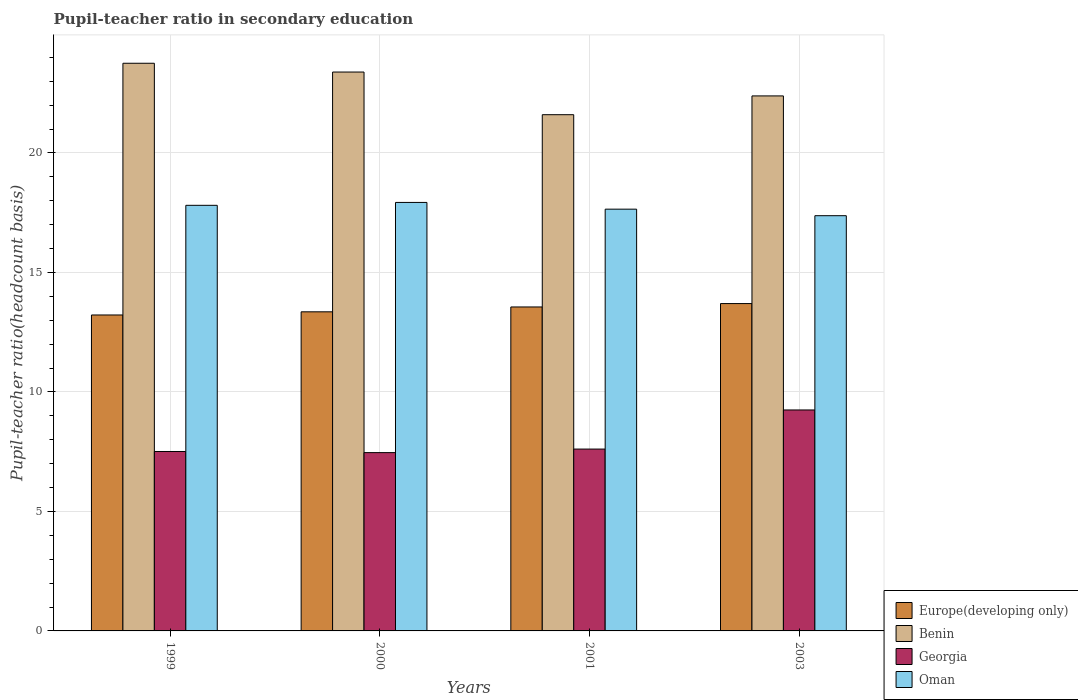How many different coloured bars are there?
Your answer should be very brief. 4. How many groups of bars are there?
Offer a terse response. 4. What is the pupil-teacher ratio in secondary education in Georgia in 1999?
Give a very brief answer. 7.51. Across all years, what is the maximum pupil-teacher ratio in secondary education in Georgia?
Keep it short and to the point. 9.25. Across all years, what is the minimum pupil-teacher ratio in secondary education in Oman?
Your answer should be very brief. 17.37. In which year was the pupil-teacher ratio in secondary education in Benin minimum?
Offer a very short reply. 2001. What is the total pupil-teacher ratio in secondary education in Benin in the graph?
Your answer should be compact. 91.12. What is the difference between the pupil-teacher ratio in secondary education in Oman in 2001 and that in 2003?
Give a very brief answer. 0.27. What is the difference between the pupil-teacher ratio in secondary education in Europe(developing only) in 2001 and the pupil-teacher ratio in secondary education in Georgia in 1999?
Give a very brief answer. 6.05. What is the average pupil-teacher ratio in secondary education in Europe(developing only) per year?
Keep it short and to the point. 13.46. In the year 2003, what is the difference between the pupil-teacher ratio in secondary education in Georgia and pupil-teacher ratio in secondary education in Europe(developing only)?
Give a very brief answer. -4.45. What is the ratio of the pupil-teacher ratio in secondary education in Benin in 2000 to that in 2001?
Offer a terse response. 1.08. Is the difference between the pupil-teacher ratio in secondary education in Georgia in 1999 and 2003 greater than the difference between the pupil-teacher ratio in secondary education in Europe(developing only) in 1999 and 2003?
Make the answer very short. No. What is the difference between the highest and the second highest pupil-teacher ratio in secondary education in Europe(developing only)?
Ensure brevity in your answer.  0.14. What is the difference between the highest and the lowest pupil-teacher ratio in secondary education in Europe(developing only)?
Your response must be concise. 0.48. Is the sum of the pupil-teacher ratio in secondary education in Oman in 2001 and 2003 greater than the maximum pupil-teacher ratio in secondary education in Benin across all years?
Provide a succinct answer. Yes. What does the 4th bar from the left in 1999 represents?
Keep it short and to the point. Oman. What does the 3rd bar from the right in 2000 represents?
Give a very brief answer. Benin. Is it the case that in every year, the sum of the pupil-teacher ratio in secondary education in Oman and pupil-teacher ratio in secondary education in Benin is greater than the pupil-teacher ratio in secondary education in Georgia?
Your answer should be very brief. Yes. What is the difference between two consecutive major ticks on the Y-axis?
Offer a terse response. 5. Are the values on the major ticks of Y-axis written in scientific E-notation?
Offer a very short reply. No. Does the graph contain any zero values?
Ensure brevity in your answer.  No. Where does the legend appear in the graph?
Your answer should be compact. Bottom right. How many legend labels are there?
Provide a short and direct response. 4. How are the legend labels stacked?
Your answer should be compact. Vertical. What is the title of the graph?
Your answer should be compact. Pupil-teacher ratio in secondary education. What is the label or title of the Y-axis?
Ensure brevity in your answer.  Pupil-teacher ratio(headcount basis). What is the Pupil-teacher ratio(headcount basis) in Europe(developing only) in 1999?
Provide a succinct answer. 13.22. What is the Pupil-teacher ratio(headcount basis) in Benin in 1999?
Ensure brevity in your answer.  23.75. What is the Pupil-teacher ratio(headcount basis) of Georgia in 1999?
Offer a terse response. 7.51. What is the Pupil-teacher ratio(headcount basis) of Oman in 1999?
Provide a succinct answer. 17.81. What is the Pupil-teacher ratio(headcount basis) in Europe(developing only) in 2000?
Your answer should be very brief. 13.35. What is the Pupil-teacher ratio(headcount basis) in Benin in 2000?
Offer a terse response. 23.38. What is the Pupil-teacher ratio(headcount basis) of Georgia in 2000?
Your answer should be very brief. 7.46. What is the Pupil-teacher ratio(headcount basis) in Oman in 2000?
Offer a very short reply. 17.93. What is the Pupil-teacher ratio(headcount basis) in Europe(developing only) in 2001?
Ensure brevity in your answer.  13.55. What is the Pupil-teacher ratio(headcount basis) in Benin in 2001?
Make the answer very short. 21.6. What is the Pupil-teacher ratio(headcount basis) of Georgia in 2001?
Keep it short and to the point. 7.61. What is the Pupil-teacher ratio(headcount basis) in Oman in 2001?
Your answer should be very brief. 17.65. What is the Pupil-teacher ratio(headcount basis) in Europe(developing only) in 2003?
Provide a succinct answer. 13.7. What is the Pupil-teacher ratio(headcount basis) in Benin in 2003?
Provide a short and direct response. 22.38. What is the Pupil-teacher ratio(headcount basis) of Georgia in 2003?
Offer a very short reply. 9.25. What is the Pupil-teacher ratio(headcount basis) of Oman in 2003?
Provide a short and direct response. 17.37. Across all years, what is the maximum Pupil-teacher ratio(headcount basis) in Europe(developing only)?
Offer a terse response. 13.7. Across all years, what is the maximum Pupil-teacher ratio(headcount basis) in Benin?
Ensure brevity in your answer.  23.75. Across all years, what is the maximum Pupil-teacher ratio(headcount basis) in Georgia?
Make the answer very short. 9.25. Across all years, what is the maximum Pupil-teacher ratio(headcount basis) in Oman?
Keep it short and to the point. 17.93. Across all years, what is the minimum Pupil-teacher ratio(headcount basis) of Europe(developing only)?
Ensure brevity in your answer.  13.22. Across all years, what is the minimum Pupil-teacher ratio(headcount basis) of Benin?
Make the answer very short. 21.6. Across all years, what is the minimum Pupil-teacher ratio(headcount basis) in Georgia?
Your response must be concise. 7.46. Across all years, what is the minimum Pupil-teacher ratio(headcount basis) of Oman?
Give a very brief answer. 17.37. What is the total Pupil-teacher ratio(headcount basis) of Europe(developing only) in the graph?
Offer a terse response. 53.82. What is the total Pupil-teacher ratio(headcount basis) in Benin in the graph?
Your answer should be very brief. 91.12. What is the total Pupil-teacher ratio(headcount basis) of Georgia in the graph?
Provide a short and direct response. 31.82. What is the total Pupil-teacher ratio(headcount basis) in Oman in the graph?
Ensure brevity in your answer.  70.75. What is the difference between the Pupil-teacher ratio(headcount basis) in Europe(developing only) in 1999 and that in 2000?
Keep it short and to the point. -0.13. What is the difference between the Pupil-teacher ratio(headcount basis) in Benin in 1999 and that in 2000?
Your answer should be compact. 0.37. What is the difference between the Pupil-teacher ratio(headcount basis) of Georgia in 1999 and that in 2000?
Your answer should be very brief. 0.05. What is the difference between the Pupil-teacher ratio(headcount basis) in Oman in 1999 and that in 2000?
Give a very brief answer. -0.12. What is the difference between the Pupil-teacher ratio(headcount basis) in Europe(developing only) in 1999 and that in 2001?
Provide a short and direct response. -0.34. What is the difference between the Pupil-teacher ratio(headcount basis) of Benin in 1999 and that in 2001?
Your answer should be very brief. 2.15. What is the difference between the Pupil-teacher ratio(headcount basis) in Georgia in 1999 and that in 2001?
Provide a short and direct response. -0.1. What is the difference between the Pupil-teacher ratio(headcount basis) in Oman in 1999 and that in 2001?
Ensure brevity in your answer.  0.16. What is the difference between the Pupil-teacher ratio(headcount basis) of Europe(developing only) in 1999 and that in 2003?
Provide a succinct answer. -0.48. What is the difference between the Pupil-teacher ratio(headcount basis) of Benin in 1999 and that in 2003?
Keep it short and to the point. 1.37. What is the difference between the Pupil-teacher ratio(headcount basis) of Georgia in 1999 and that in 2003?
Offer a terse response. -1.74. What is the difference between the Pupil-teacher ratio(headcount basis) in Oman in 1999 and that in 2003?
Your response must be concise. 0.43. What is the difference between the Pupil-teacher ratio(headcount basis) of Europe(developing only) in 2000 and that in 2001?
Keep it short and to the point. -0.2. What is the difference between the Pupil-teacher ratio(headcount basis) in Benin in 2000 and that in 2001?
Your response must be concise. 1.78. What is the difference between the Pupil-teacher ratio(headcount basis) of Georgia in 2000 and that in 2001?
Offer a very short reply. -0.15. What is the difference between the Pupil-teacher ratio(headcount basis) in Oman in 2000 and that in 2001?
Make the answer very short. 0.28. What is the difference between the Pupil-teacher ratio(headcount basis) in Europe(developing only) in 2000 and that in 2003?
Your answer should be very brief. -0.35. What is the difference between the Pupil-teacher ratio(headcount basis) in Georgia in 2000 and that in 2003?
Your response must be concise. -1.78. What is the difference between the Pupil-teacher ratio(headcount basis) in Oman in 2000 and that in 2003?
Keep it short and to the point. 0.56. What is the difference between the Pupil-teacher ratio(headcount basis) in Europe(developing only) in 2001 and that in 2003?
Offer a terse response. -0.14. What is the difference between the Pupil-teacher ratio(headcount basis) of Benin in 2001 and that in 2003?
Provide a succinct answer. -0.79. What is the difference between the Pupil-teacher ratio(headcount basis) of Georgia in 2001 and that in 2003?
Your answer should be compact. -1.64. What is the difference between the Pupil-teacher ratio(headcount basis) in Oman in 2001 and that in 2003?
Provide a succinct answer. 0.27. What is the difference between the Pupil-teacher ratio(headcount basis) in Europe(developing only) in 1999 and the Pupil-teacher ratio(headcount basis) in Benin in 2000?
Your answer should be compact. -10.16. What is the difference between the Pupil-teacher ratio(headcount basis) of Europe(developing only) in 1999 and the Pupil-teacher ratio(headcount basis) of Georgia in 2000?
Make the answer very short. 5.76. What is the difference between the Pupil-teacher ratio(headcount basis) in Europe(developing only) in 1999 and the Pupil-teacher ratio(headcount basis) in Oman in 2000?
Offer a terse response. -4.71. What is the difference between the Pupil-teacher ratio(headcount basis) in Benin in 1999 and the Pupil-teacher ratio(headcount basis) in Georgia in 2000?
Give a very brief answer. 16.29. What is the difference between the Pupil-teacher ratio(headcount basis) of Benin in 1999 and the Pupil-teacher ratio(headcount basis) of Oman in 2000?
Offer a terse response. 5.82. What is the difference between the Pupil-teacher ratio(headcount basis) of Georgia in 1999 and the Pupil-teacher ratio(headcount basis) of Oman in 2000?
Make the answer very short. -10.42. What is the difference between the Pupil-teacher ratio(headcount basis) of Europe(developing only) in 1999 and the Pupil-teacher ratio(headcount basis) of Benin in 2001?
Offer a very short reply. -8.38. What is the difference between the Pupil-teacher ratio(headcount basis) in Europe(developing only) in 1999 and the Pupil-teacher ratio(headcount basis) in Georgia in 2001?
Offer a very short reply. 5.61. What is the difference between the Pupil-teacher ratio(headcount basis) in Europe(developing only) in 1999 and the Pupil-teacher ratio(headcount basis) in Oman in 2001?
Offer a very short reply. -4.43. What is the difference between the Pupil-teacher ratio(headcount basis) in Benin in 1999 and the Pupil-teacher ratio(headcount basis) in Georgia in 2001?
Provide a succinct answer. 16.14. What is the difference between the Pupil-teacher ratio(headcount basis) of Benin in 1999 and the Pupil-teacher ratio(headcount basis) of Oman in 2001?
Offer a terse response. 6.1. What is the difference between the Pupil-teacher ratio(headcount basis) in Georgia in 1999 and the Pupil-teacher ratio(headcount basis) in Oman in 2001?
Provide a short and direct response. -10.14. What is the difference between the Pupil-teacher ratio(headcount basis) of Europe(developing only) in 1999 and the Pupil-teacher ratio(headcount basis) of Benin in 2003?
Provide a short and direct response. -9.17. What is the difference between the Pupil-teacher ratio(headcount basis) of Europe(developing only) in 1999 and the Pupil-teacher ratio(headcount basis) of Georgia in 2003?
Provide a succinct answer. 3.97. What is the difference between the Pupil-teacher ratio(headcount basis) in Europe(developing only) in 1999 and the Pupil-teacher ratio(headcount basis) in Oman in 2003?
Your answer should be compact. -4.15. What is the difference between the Pupil-teacher ratio(headcount basis) in Benin in 1999 and the Pupil-teacher ratio(headcount basis) in Georgia in 2003?
Give a very brief answer. 14.51. What is the difference between the Pupil-teacher ratio(headcount basis) in Benin in 1999 and the Pupil-teacher ratio(headcount basis) in Oman in 2003?
Keep it short and to the point. 6.38. What is the difference between the Pupil-teacher ratio(headcount basis) in Georgia in 1999 and the Pupil-teacher ratio(headcount basis) in Oman in 2003?
Your response must be concise. -9.87. What is the difference between the Pupil-teacher ratio(headcount basis) of Europe(developing only) in 2000 and the Pupil-teacher ratio(headcount basis) of Benin in 2001?
Provide a short and direct response. -8.25. What is the difference between the Pupil-teacher ratio(headcount basis) of Europe(developing only) in 2000 and the Pupil-teacher ratio(headcount basis) of Georgia in 2001?
Your answer should be very brief. 5.74. What is the difference between the Pupil-teacher ratio(headcount basis) of Europe(developing only) in 2000 and the Pupil-teacher ratio(headcount basis) of Oman in 2001?
Provide a succinct answer. -4.3. What is the difference between the Pupil-teacher ratio(headcount basis) of Benin in 2000 and the Pupil-teacher ratio(headcount basis) of Georgia in 2001?
Provide a succinct answer. 15.78. What is the difference between the Pupil-teacher ratio(headcount basis) of Benin in 2000 and the Pupil-teacher ratio(headcount basis) of Oman in 2001?
Provide a short and direct response. 5.74. What is the difference between the Pupil-teacher ratio(headcount basis) in Georgia in 2000 and the Pupil-teacher ratio(headcount basis) in Oman in 2001?
Make the answer very short. -10.19. What is the difference between the Pupil-teacher ratio(headcount basis) of Europe(developing only) in 2000 and the Pupil-teacher ratio(headcount basis) of Benin in 2003?
Ensure brevity in your answer.  -9.03. What is the difference between the Pupil-teacher ratio(headcount basis) in Europe(developing only) in 2000 and the Pupil-teacher ratio(headcount basis) in Georgia in 2003?
Ensure brevity in your answer.  4.11. What is the difference between the Pupil-teacher ratio(headcount basis) of Europe(developing only) in 2000 and the Pupil-teacher ratio(headcount basis) of Oman in 2003?
Offer a very short reply. -4.02. What is the difference between the Pupil-teacher ratio(headcount basis) of Benin in 2000 and the Pupil-teacher ratio(headcount basis) of Georgia in 2003?
Your response must be concise. 14.14. What is the difference between the Pupil-teacher ratio(headcount basis) in Benin in 2000 and the Pupil-teacher ratio(headcount basis) in Oman in 2003?
Make the answer very short. 6.01. What is the difference between the Pupil-teacher ratio(headcount basis) in Georgia in 2000 and the Pupil-teacher ratio(headcount basis) in Oman in 2003?
Ensure brevity in your answer.  -9.91. What is the difference between the Pupil-teacher ratio(headcount basis) in Europe(developing only) in 2001 and the Pupil-teacher ratio(headcount basis) in Benin in 2003?
Ensure brevity in your answer.  -8.83. What is the difference between the Pupil-teacher ratio(headcount basis) in Europe(developing only) in 2001 and the Pupil-teacher ratio(headcount basis) in Georgia in 2003?
Make the answer very short. 4.31. What is the difference between the Pupil-teacher ratio(headcount basis) in Europe(developing only) in 2001 and the Pupil-teacher ratio(headcount basis) in Oman in 2003?
Your answer should be very brief. -3.82. What is the difference between the Pupil-teacher ratio(headcount basis) of Benin in 2001 and the Pupil-teacher ratio(headcount basis) of Georgia in 2003?
Provide a short and direct response. 12.35. What is the difference between the Pupil-teacher ratio(headcount basis) in Benin in 2001 and the Pupil-teacher ratio(headcount basis) in Oman in 2003?
Offer a terse response. 4.23. What is the difference between the Pupil-teacher ratio(headcount basis) of Georgia in 2001 and the Pupil-teacher ratio(headcount basis) of Oman in 2003?
Provide a succinct answer. -9.76. What is the average Pupil-teacher ratio(headcount basis) in Europe(developing only) per year?
Provide a short and direct response. 13.46. What is the average Pupil-teacher ratio(headcount basis) of Benin per year?
Offer a very short reply. 22.78. What is the average Pupil-teacher ratio(headcount basis) in Georgia per year?
Provide a short and direct response. 7.96. What is the average Pupil-teacher ratio(headcount basis) in Oman per year?
Your answer should be compact. 17.69. In the year 1999, what is the difference between the Pupil-teacher ratio(headcount basis) of Europe(developing only) and Pupil-teacher ratio(headcount basis) of Benin?
Your answer should be compact. -10.53. In the year 1999, what is the difference between the Pupil-teacher ratio(headcount basis) in Europe(developing only) and Pupil-teacher ratio(headcount basis) in Georgia?
Offer a very short reply. 5.71. In the year 1999, what is the difference between the Pupil-teacher ratio(headcount basis) of Europe(developing only) and Pupil-teacher ratio(headcount basis) of Oman?
Your answer should be compact. -4.59. In the year 1999, what is the difference between the Pupil-teacher ratio(headcount basis) in Benin and Pupil-teacher ratio(headcount basis) in Georgia?
Provide a short and direct response. 16.24. In the year 1999, what is the difference between the Pupil-teacher ratio(headcount basis) of Benin and Pupil-teacher ratio(headcount basis) of Oman?
Provide a succinct answer. 5.94. In the year 1999, what is the difference between the Pupil-teacher ratio(headcount basis) in Georgia and Pupil-teacher ratio(headcount basis) in Oman?
Ensure brevity in your answer.  -10.3. In the year 2000, what is the difference between the Pupil-teacher ratio(headcount basis) in Europe(developing only) and Pupil-teacher ratio(headcount basis) in Benin?
Keep it short and to the point. -10.03. In the year 2000, what is the difference between the Pupil-teacher ratio(headcount basis) of Europe(developing only) and Pupil-teacher ratio(headcount basis) of Georgia?
Offer a terse response. 5.89. In the year 2000, what is the difference between the Pupil-teacher ratio(headcount basis) of Europe(developing only) and Pupil-teacher ratio(headcount basis) of Oman?
Offer a terse response. -4.58. In the year 2000, what is the difference between the Pupil-teacher ratio(headcount basis) of Benin and Pupil-teacher ratio(headcount basis) of Georgia?
Provide a succinct answer. 15.92. In the year 2000, what is the difference between the Pupil-teacher ratio(headcount basis) in Benin and Pupil-teacher ratio(headcount basis) in Oman?
Make the answer very short. 5.46. In the year 2000, what is the difference between the Pupil-teacher ratio(headcount basis) of Georgia and Pupil-teacher ratio(headcount basis) of Oman?
Your answer should be very brief. -10.47. In the year 2001, what is the difference between the Pupil-teacher ratio(headcount basis) in Europe(developing only) and Pupil-teacher ratio(headcount basis) in Benin?
Offer a terse response. -8.04. In the year 2001, what is the difference between the Pupil-teacher ratio(headcount basis) in Europe(developing only) and Pupil-teacher ratio(headcount basis) in Georgia?
Give a very brief answer. 5.95. In the year 2001, what is the difference between the Pupil-teacher ratio(headcount basis) of Europe(developing only) and Pupil-teacher ratio(headcount basis) of Oman?
Your response must be concise. -4.09. In the year 2001, what is the difference between the Pupil-teacher ratio(headcount basis) in Benin and Pupil-teacher ratio(headcount basis) in Georgia?
Ensure brevity in your answer.  13.99. In the year 2001, what is the difference between the Pupil-teacher ratio(headcount basis) of Benin and Pupil-teacher ratio(headcount basis) of Oman?
Your answer should be very brief. 3.95. In the year 2001, what is the difference between the Pupil-teacher ratio(headcount basis) of Georgia and Pupil-teacher ratio(headcount basis) of Oman?
Provide a short and direct response. -10.04. In the year 2003, what is the difference between the Pupil-teacher ratio(headcount basis) in Europe(developing only) and Pupil-teacher ratio(headcount basis) in Benin?
Offer a very short reply. -8.69. In the year 2003, what is the difference between the Pupil-teacher ratio(headcount basis) of Europe(developing only) and Pupil-teacher ratio(headcount basis) of Georgia?
Provide a short and direct response. 4.45. In the year 2003, what is the difference between the Pupil-teacher ratio(headcount basis) in Europe(developing only) and Pupil-teacher ratio(headcount basis) in Oman?
Keep it short and to the point. -3.68. In the year 2003, what is the difference between the Pupil-teacher ratio(headcount basis) in Benin and Pupil-teacher ratio(headcount basis) in Georgia?
Your response must be concise. 13.14. In the year 2003, what is the difference between the Pupil-teacher ratio(headcount basis) in Benin and Pupil-teacher ratio(headcount basis) in Oman?
Keep it short and to the point. 5.01. In the year 2003, what is the difference between the Pupil-teacher ratio(headcount basis) in Georgia and Pupil-teacher ratio(headcount basis) in Oman?
Your response must be concise. -8.13. What is the ratio of the Pupil-teacher ratio(headcount basis) of Benin in 1999 to that in 2000?
Provide a short and direct response. 1.02. What is the ratio of the Pupil-teacher ratio(headcount basis) of Oman in 1999 to that in 2000?
Provide a succinct answer. 0.99. What is the ratio of the Pupil-teacher ratio(headcount basis) in Europe(developing only) in 1999 to that in 2001?
Make the answer very short. 0.98. What is the ratio of the Pupil-teacher ratio(headcount basis) of Benin in 1999 to that in 2001?
Your answer should be very brief. 1.1. What is the ratio of the Pupil-teacher ratio(headcount basis) in Georgia in 1999 to that in 2001?
Keep it short and to the point. 0.99. What is the ratio of the Pupil-teacher ratio(headcount basis) of Oman in 1999 to that in 2001?
Keep it short and to the point. 1.01. What is the ratio of the Pupil-teacher ratio(headcount basis) of Europe(developing only) in 1999 to that in 2003?
Offer a terse response. 0.97. What is the ratio of the Pupil-teacher ratio(headcount basis) of Benin in 1999 to that in 2003?
Ensure brevity in your answer.  1.06. What is the ratio of the Pupil-teacher ratio(headcount basis) in Georgia in 1999 to that in 2003?
Provide a succinct answer. 0.81. What is the ratio of the Pupil-teacher ratio(headcount basis) in Oman in 1999 to that in 2003?
Offer a very short reply. 1.02. What is the ratio of the Pupil-teacher ratio(headcount basis) of Europe(developing only) in 2000 to that in 2001?
Offer a very short reply. 0.98. What is the ratio of the Pupil-teacher ratio(headcount basis) in Benin in 2000 to that in 2001?
Make the answer very short. 1.08. What is the ratio of the Pupil-teacher ratio(headcount basis) of Georgia in 2000 to that in 2001?
Your answer should be very brief. 0.98. What is the ratio of the Pupil-teacher ratio(headcount basis) of Oman in 2000 to that in 2001?
Keep it short and to the point. 1.02. What is the ratio of the Pupil-teacher ratio(headcount basis) of Europe(developing only) in 2000 to that in 2003?
Your response must be concise. 0.97. What is the ratio of the Pupil-teacher ratio(headcount basis) of Benin in 2000 to that in 2003?
Your response must be concise. 1.04. What is the ratio of the Pupil-teacher ratio(headcount basis) in Georgia in 2000 to that in 2003?
Give a very brief answer. 0.81. What is the ratio of the Pupil-teacher ratio(headcount basis) of Oman in 2000 to that in 2003?
Your response must be concise. 1.03. What is the ratio of the Pupil-teacher ratio(headcount basis) of Europe(developing only) in 2001 to that in 2003?
Ensure brevity in your answer.  0.99. What is the ratio of the Pupil-teacher ratio(headcount basis) in Benin in 2001 to that in 2003?
Make the answer very short. 0.96. What is the ratio of the Pupil-teacher ratio(headcount basis) in Georgia in 2001 to that in 2003?
Your answer should be very brief. 0.82. What is the ratio of the Pupil-teacher ratio(headcount basis) of Oman in 2001 to that in 2003?
Ensure brevity in your answer.  1.02. What is the difference between the highest and the second highest Pupil-teacher ratio(headcount basis) in Europe(developing only)?
Your answer should be very brief. 0.14. What is the difference between the highest and the second highest Pupil-teacher ratio(headcount basis) in Benin?
Ensure brevity in your answer.  0.37. What is the difference between the highest and the second highest Pupil-teacher ratio(headcount basis) of Georgia?
Provide a short and direct response. 1.64. What is the difference between the highest and the second highest Pupil-teacher ratio(headcount basis) of Oman?
Keep it short and to the point. 0.12. What is the difference between the highest and the lowest Pupil-teacher ratio(headcount basis) in Europe(developing only)?
Provide a succinct answer. 0.48. What is the difference between the highest and the lowest Pupil-teacher ratio(headcount basis) of Benin?
Give a very brief answer. 2.15. What is the difference between the highest and the lowest Pupil-teacher ratio(headcount basis) of Georgia?
Your answer should be compact. 1.78. What is the difference between the highest and the lowest Pupil-teacher ratio(headcount basis) of Oman?
Keep it short and to the point. 0.56. 